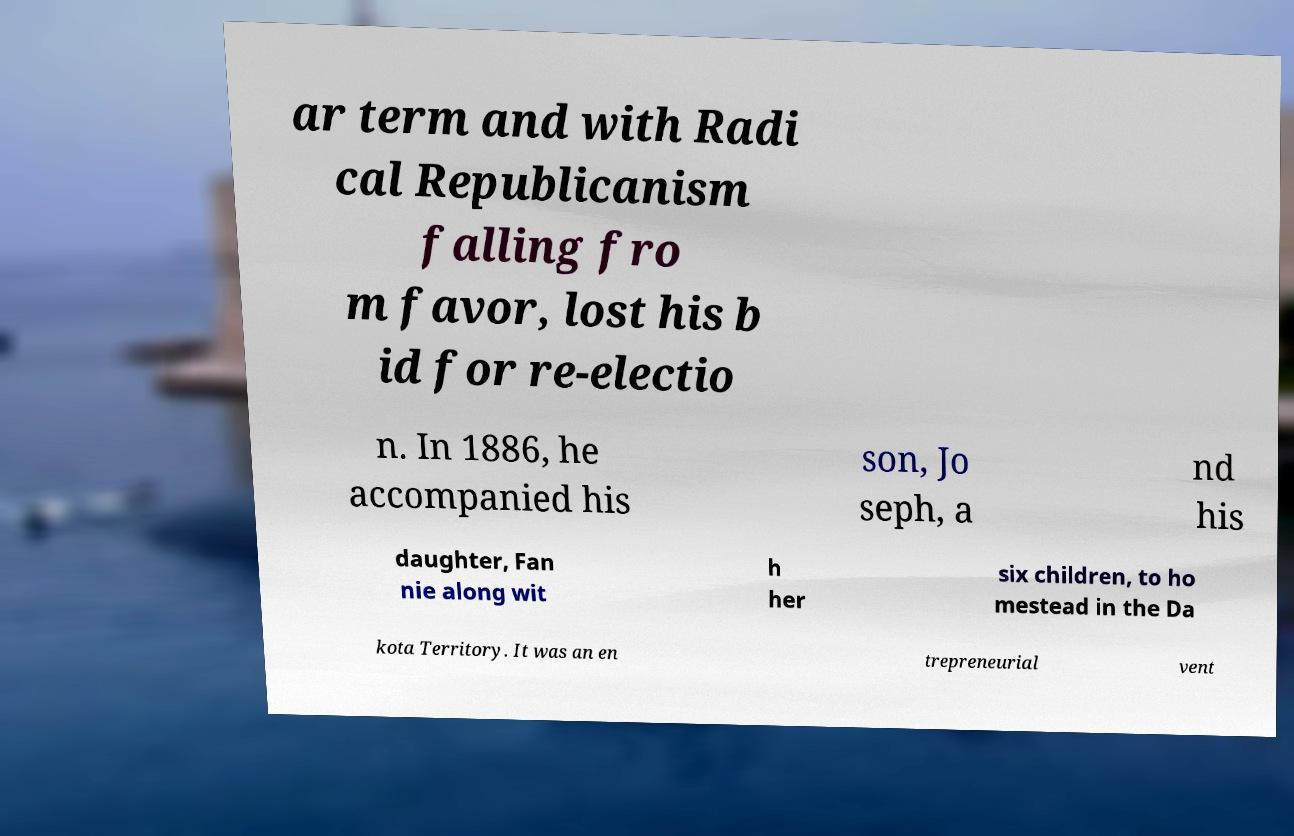For documentation purposes, I need the text within this image transcribed. Could you provide that? ar term and with Radi cal Republicanism falling fro m favor, lost his b id for re-electio n. In 1886, he accompanied his son, Jo seph, a nd his daughter, Fan nie along wit h her six children, to ho mestead in the Da kota Territory. It was an en trepreneurial vent 